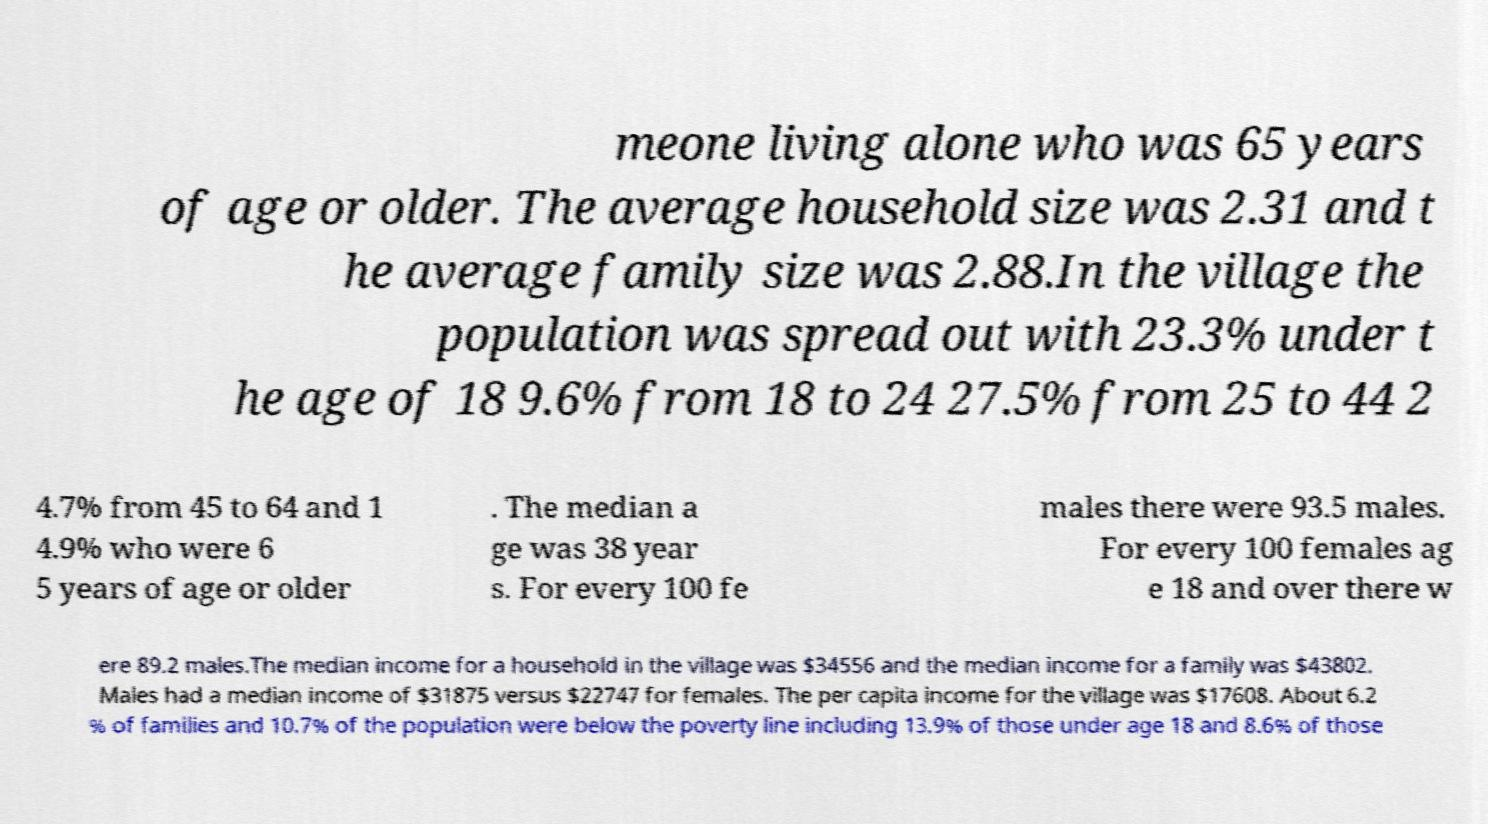Could you extract and type out the text from this image? meone living alone who was 65 years of age or older. The average household size was 2.31 and t he average family size was 2.88.In the village the population was spread out with 23.3% under t he age of 18 9.6% from 18 to 24 27.5% from 25 to 44 2 4.7% from 45 to 64 and 1 4.9% who were 6 5 years of age or older . The median a ge was 38 year s. For every 100 fe males there were 93.5 males. For every 100 females ag e 18 and over there w ere 89.2 males.The median income for a household in the village was $34556 and the median income for a family was $43802. Males had a median income of $31875 versus $22747 for females. The per capita income for the village was $17608. About 6.2 % of families and 10.7% of the population were below the poverty line including 13.9% of those under age 18 and 8.6% of those 